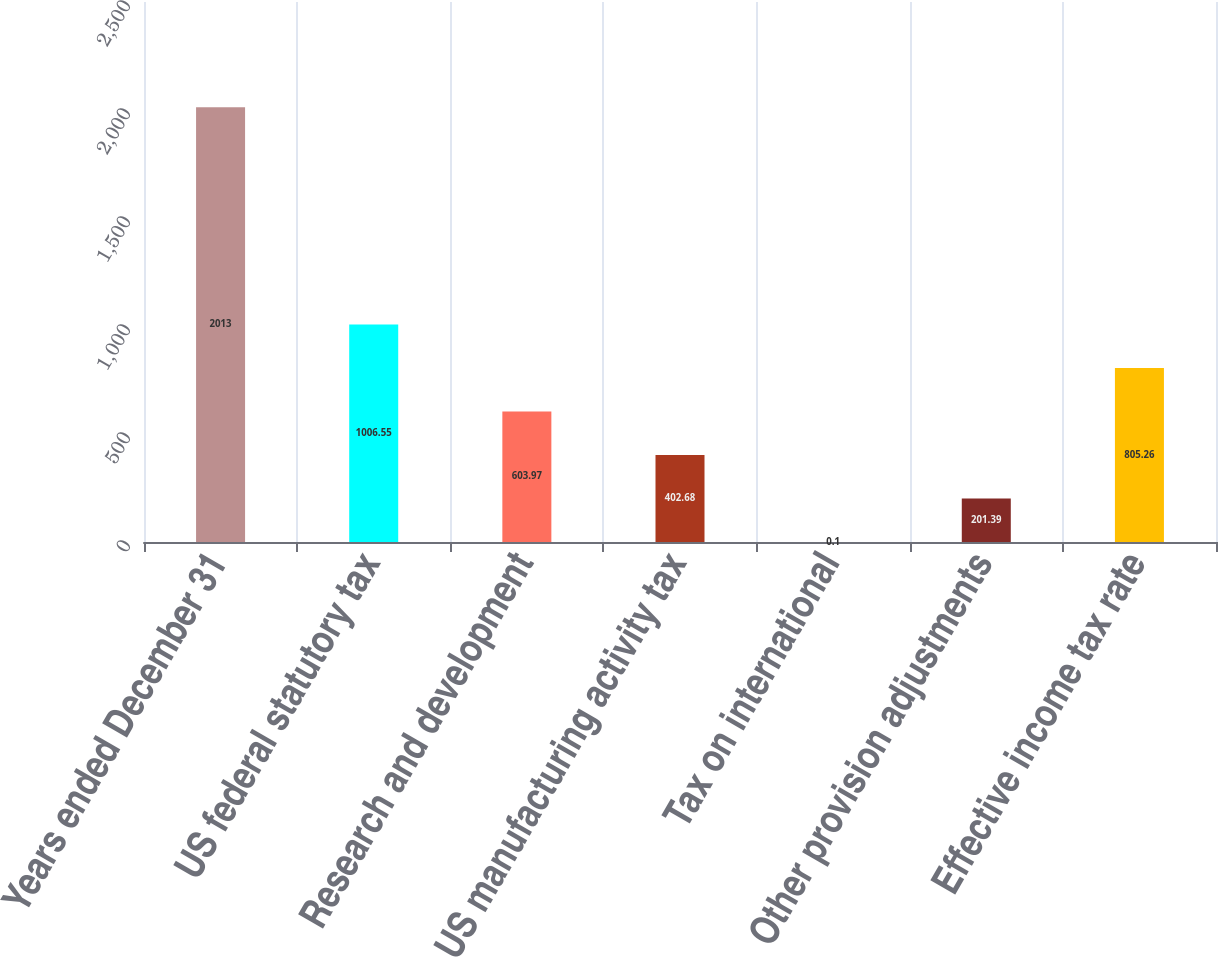Convert chart to OTSL. <chart><loc_0><loc_0><loc_500><loc_500><bar_chart><fcel>Years ended December 31<fcel>US federal statutory tax<fcel>Research and development<fcel>US manufacturing activity tax<fcel>Tax on international<fcel>Other provision adjustments<fcel>Effective income tax rate<nl><fcel>2013<fcel>1006.55<fcel>603.97<fcel>402.68<fcel>0.1<fcel>201.39<fcel>805.26<nl></chart> 